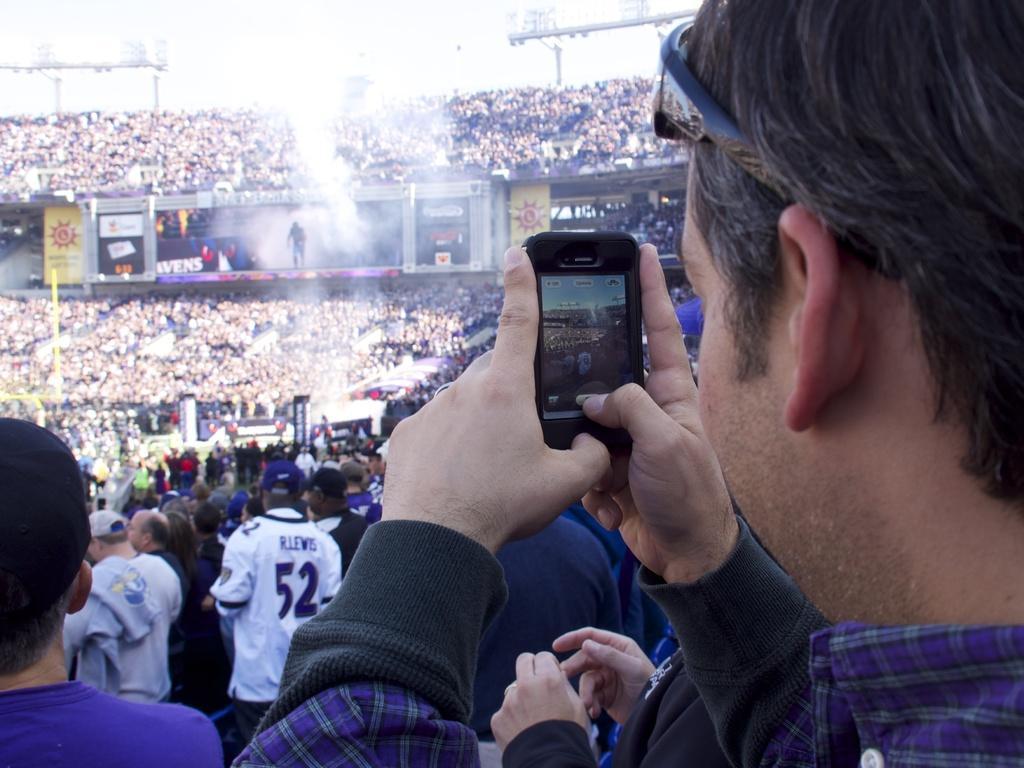In one or two sentences, can you explain what this image depicts? This is a image consist of a number of a audience on the auditorium ,there are the group of people stand in the auditorium. And right side a man taking a picture on his mobile phone. 